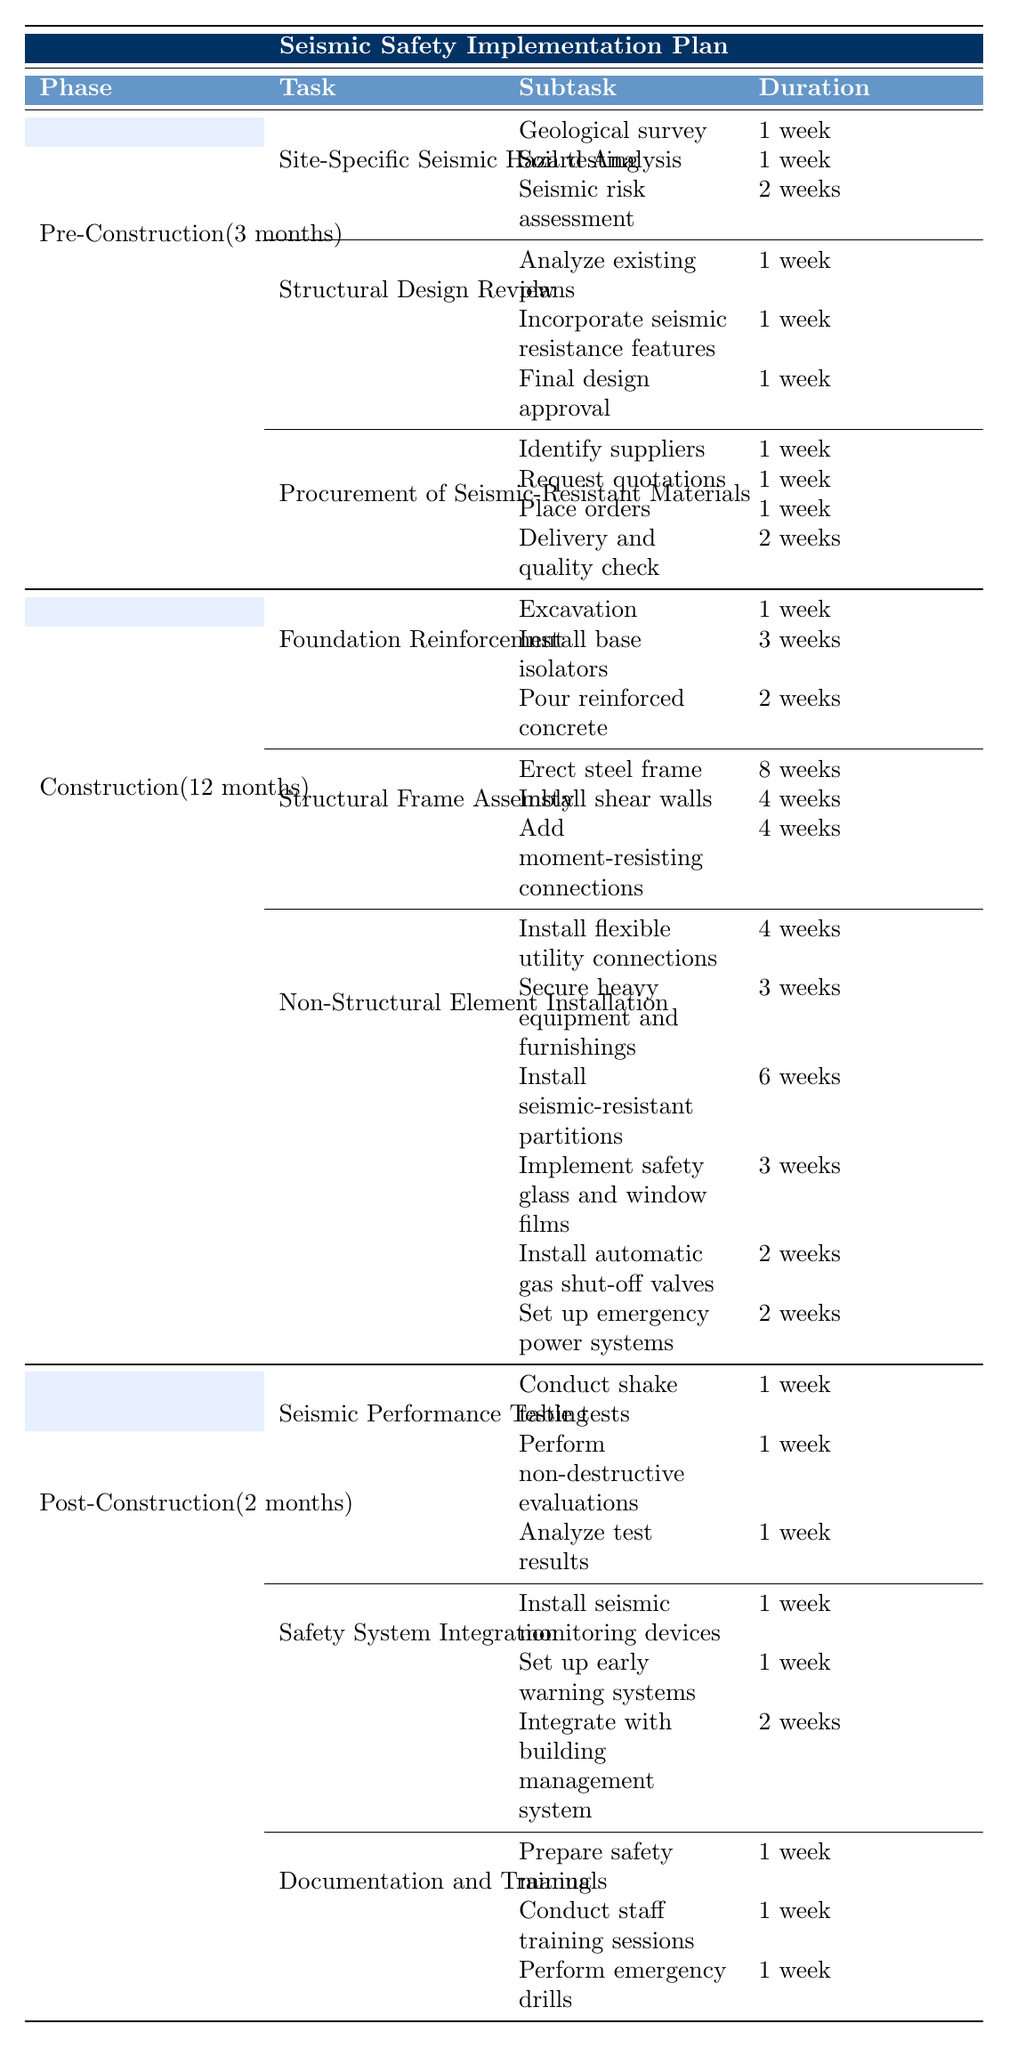What is the total duration of the Pre-Construction phase? The Pre-Construction phase has a total duration of 3 months, which is specified directly in the table.
Answer: 3 months How many weeks does the procurement of seismic-resistant materials take? The task “Procurement of Seismic-Resistant Materials” takes a total of 5 weeks, indicated in the duration column under this task.
Answer: 5 weeks Which task includes installing seismic monitoring devices? The task that includes installing seismic monitoring devices is “Safety System Integration,” as shown in the table.
Answer: Safety System Integration What is the total duration for Non-Structural Element Installation? The total duration for Non-Structural Element Installation is 20 weeks, which is provided in the Duration column for this task.
Answer: 20 weeks Is the "Structural Design Review" task completed within 2 weeks? No, the “Structural Design Review” task takes 3 weeks, as noted in the Duration column for this task.
Answer: No What is the sum of the durations for all subtasks under "Foundation Reinforcement"? The durations for the subtasks under "Foundation Reinforcement" are: 1 week (excavation) + 3 weeks (install base isolators) + 2 weeks (pour reinforced concrete) = 6 weeks, which matches the task duration.
Answer: 6 weeks What percentage of the total Pre-Construction duration is spent on the Site-Specific Seismic Hazard Analysis task? The Site-Specific Seismic Hazard Analysis task takes 4 weeks out of a total of 12 weeks (3 months) in the Pre-Construction phase. Therefore, (4 weeks / 12 weeks) * 100 = 33.33%.
Answer: 33.33% If a project is divided into Phases, what is the longest phase duration? The longest phase is the Construction phase lasting 12 months compared to the other phases (Pre-Construction 3 months and Post-Construction 2 months).
Answer: 12 months How many tasks include multiple subtasks under the Construction phase? The Construction phase has two tasks ("Non-Structural Element Installation" and "Structural Frame Assembly") that include multiple subtasks noted in the table.
Answer: 2 tasks What is the total number of weeks allocated for Seismic Performance Testing? The Seismic Performance Testing task has a total duration of 3 weeks, with its subtasks also indicating this total.
Answer: 3 weeks 